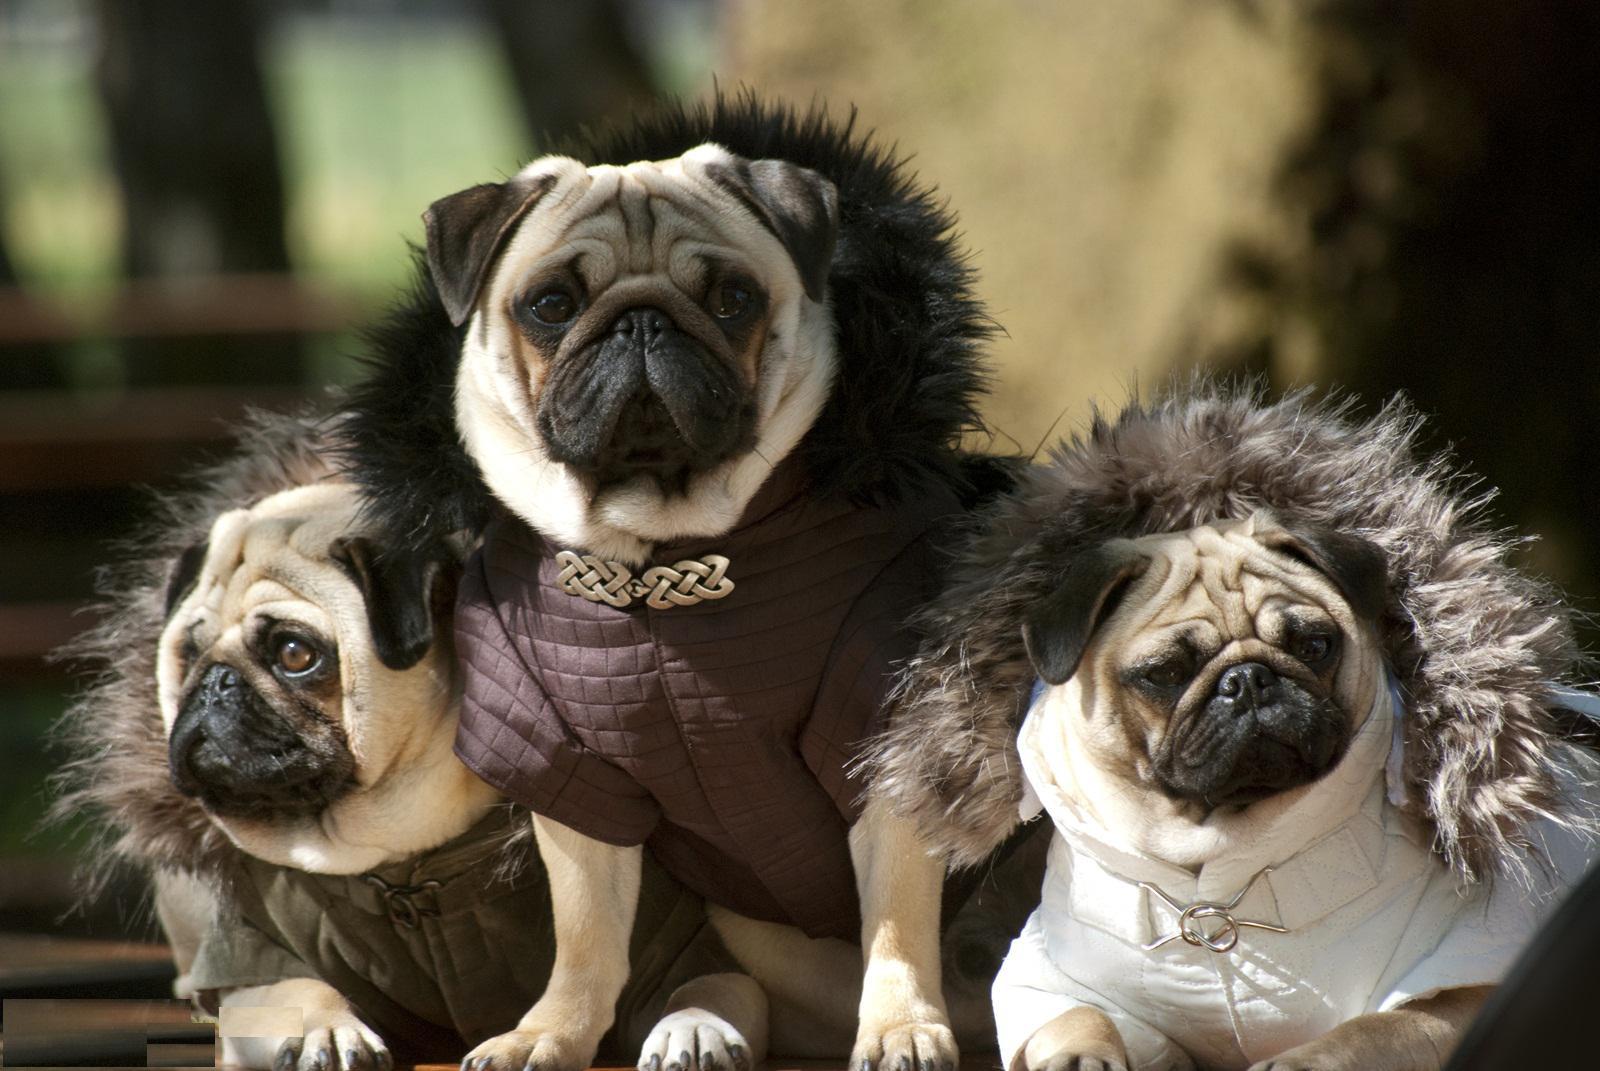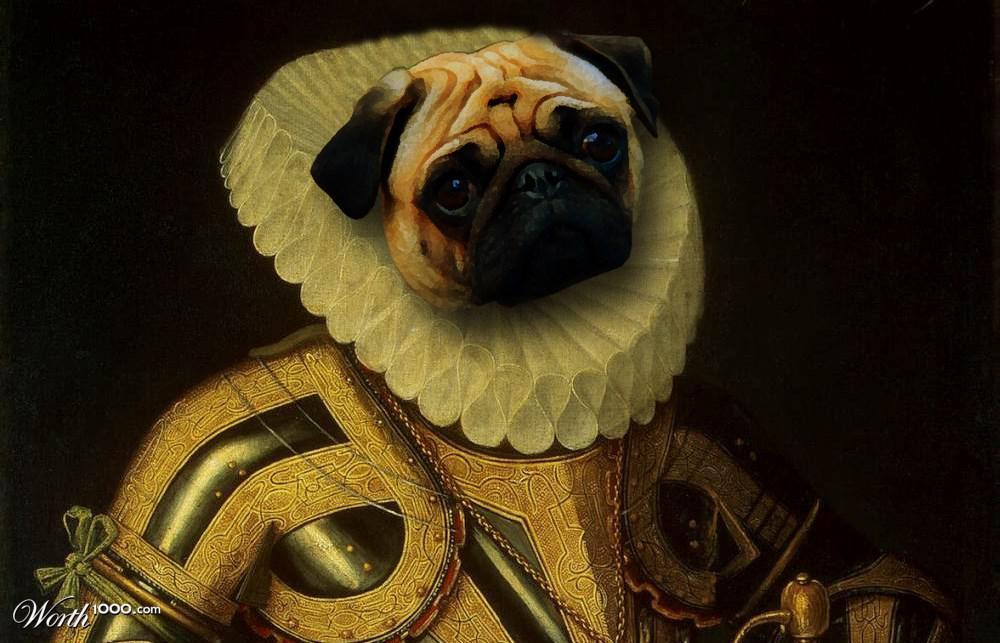The first image is the image on the left, the second image is the image on the right. For the images shown, is this caption "There are at least four dressed up pugs." true? Answer yes or no. Yes. The first image is the image on the left, the second image is the image on the right. Evaluate the accuracy of this statement regarding the images: "Three small dogs stand next to each other dressed in costume.". Is it true? Answer yes or no. Yes. 